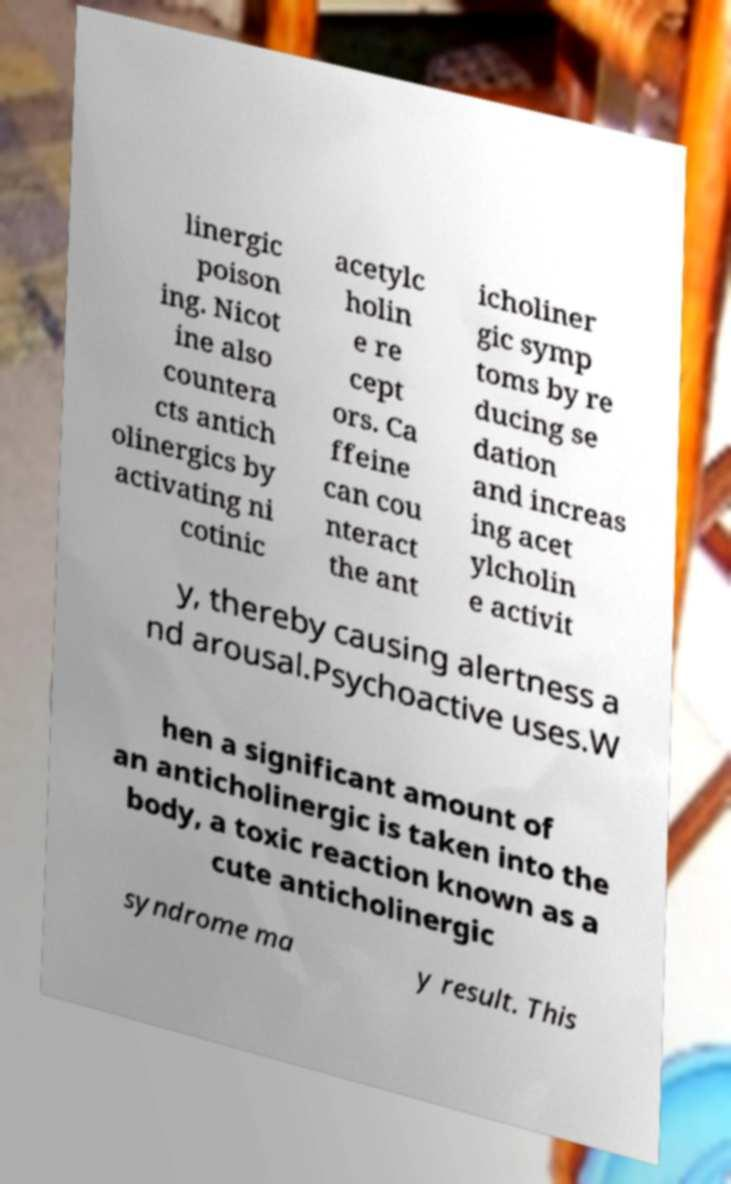What messages or text are displayed in this image? I need them in a readable, typed format. linergic poison ing. Nicot ine also countera cts antich olinergics by activating ni cotinic acetylc holin e re cept ors. Ca ffeine can cou nteract the ant icholiner gic symp toms by re ducing se dation and increas ing acet ylcholin e activit y, thereby causing alertness a nd arousal.Psychoactive uses.W hen a significant amount of an anticholinergic is taken into the body, a toxic reaction known as a cute anticholinergic syndrome ma y result. This 